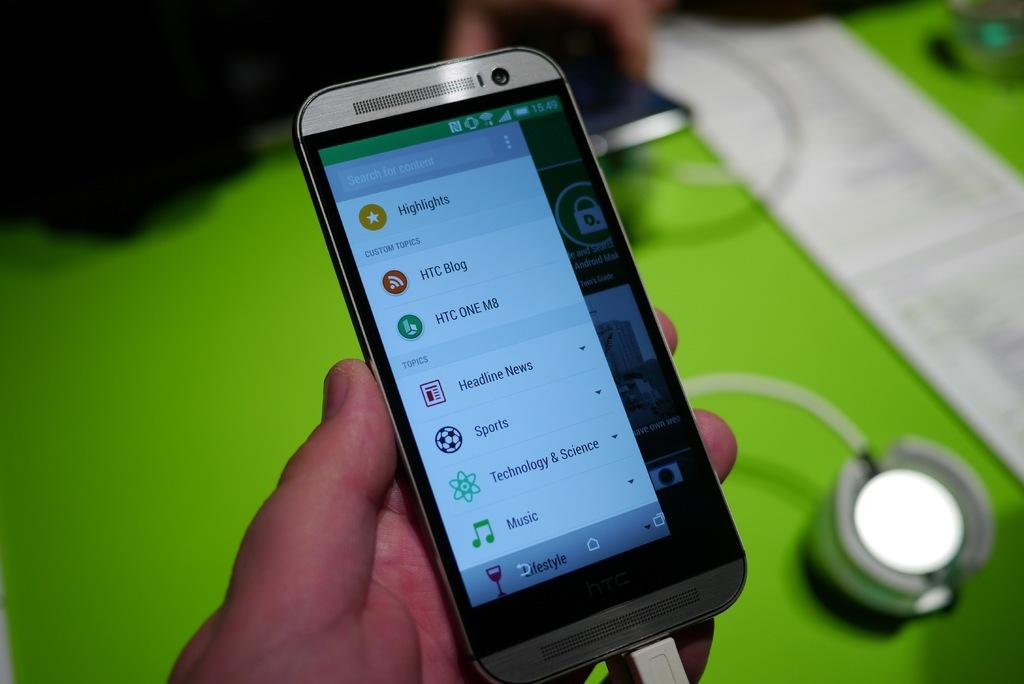What does the top option with the orange icon say?
Your answer should be very brief. Highlights. What app has a wine glass icon?
Keep it short and to the point. Lifestyle. 